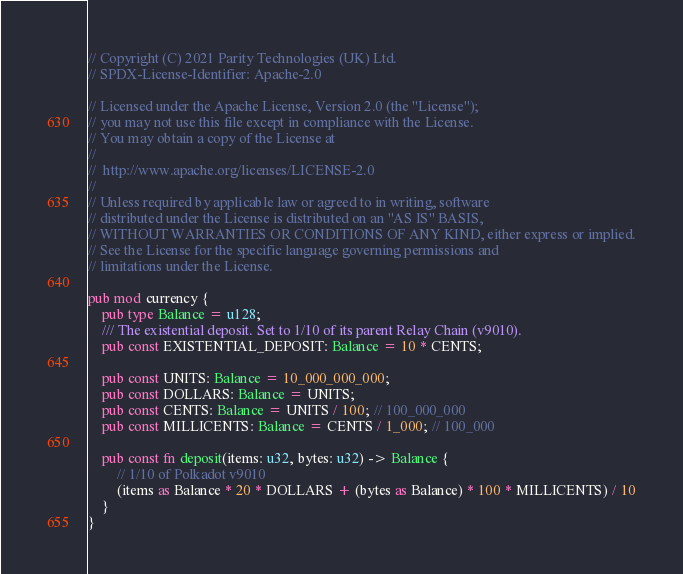<code> <loc_0><loc_0><loc_500><loc_500><_Rust_>// Copyright (C) 2021 Parity Technologies (UK) Ltd.
// SPDX-License-Identifier: Apache-2.0

// Licensed under the Apache License, Version 2.0 (the "License");
// you may not use this file except in compliance with the License.
// You may obtain a copy of the License at
//
// 	http://www.apache.org/licenses/LICENSE-2.0
//
// Unless required by applicable law or agreed to in writing, software
// distributed under the License is distributed on an "AS IS" BASIS,
// WITHOUT WARRANTIES OR CONDITIONS OF ANY KIND, either express or implied.
// See the License for the specific language governing permissions and
// limitations under the License.

pub mod currency {
	pub type Balance = u128;
	/// The existential deposit. Set to 1/10 of its parent Relay Chain (v9010).
	pub const EXISTENTIAL_DEPOSIT: Balance = 10 * CENTS;

	pub const UNITS: Balance = 10_000_000_000;
	pub const DOLLARS: Balance = UNITS;
	pub const CENTS: Balance = UNITS / 100; // 100_000_000
	pub const MILLICENTS: Balance = CENTS / 1_000; // 100_000

	pub const fn deposit(items: u32, bytes: u32) -> Balance {
		// 1/10 of Polkadot v9010
		(items as Balance * 20 * DOLLARS + (bytes as Balance) * 100 * MILLICENTS) / 10
	}
}
</code> 